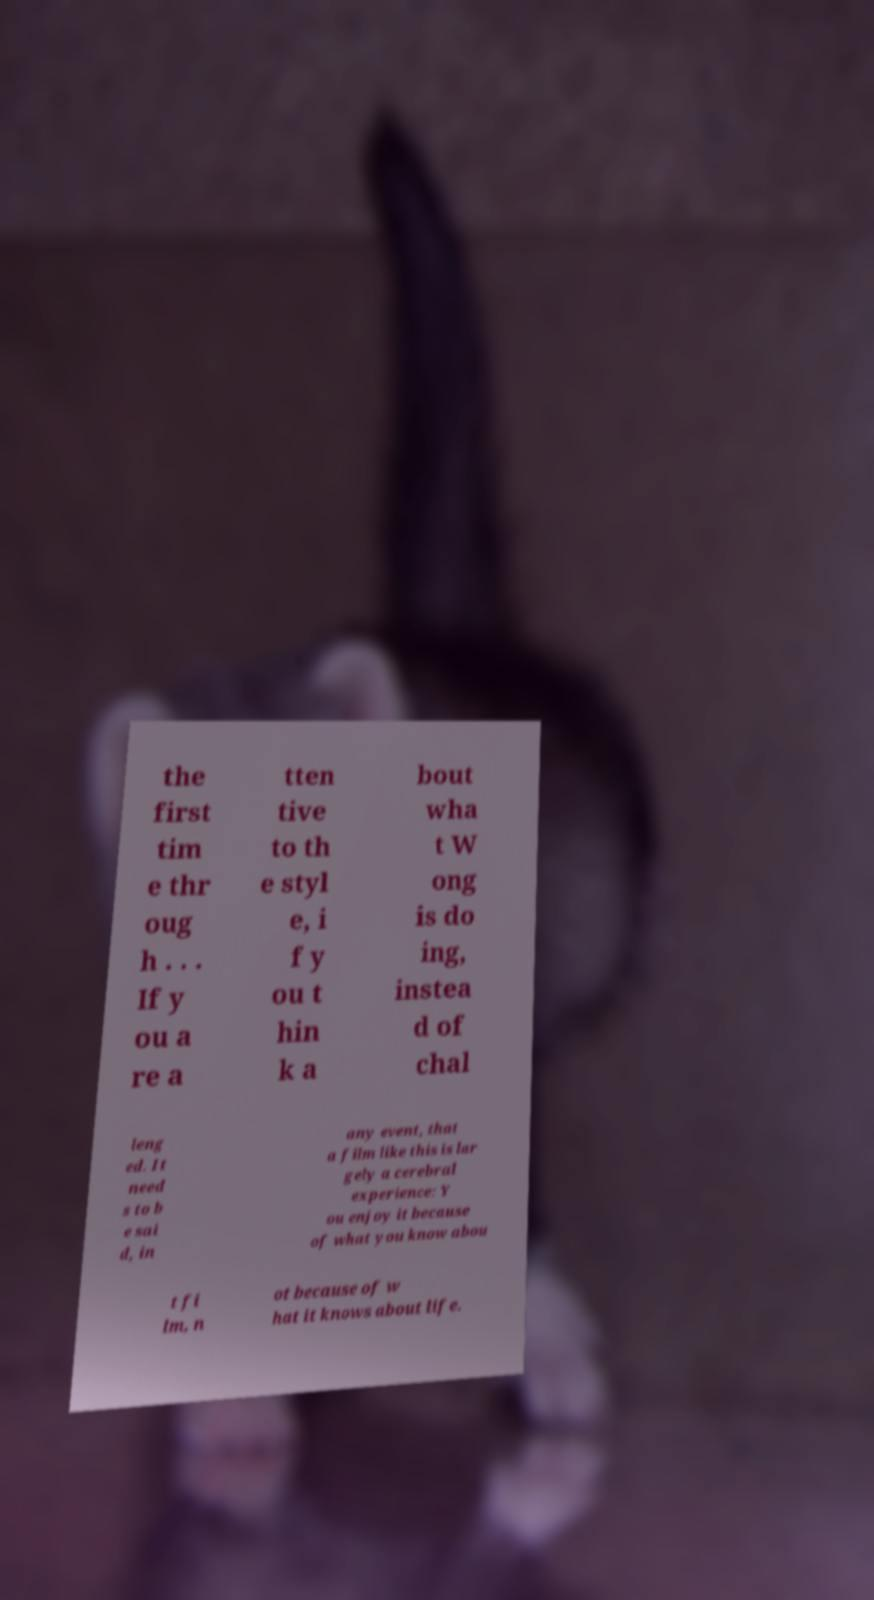What messages or text are displayed in this image? I need them in a readable, typed format. the first tim e thr oug h . . . If y ou a re a tten tive to th e styl e, i f y ou t hin k a bout wha t W ong is do ing, instea d of chal leng ed. It need s to b e sai d, in any event, that a film like this is lar gely a cerebral experience: Y ou enjoy it because of what you know abou t fi lm, n ot because of w hat it knows about life. 